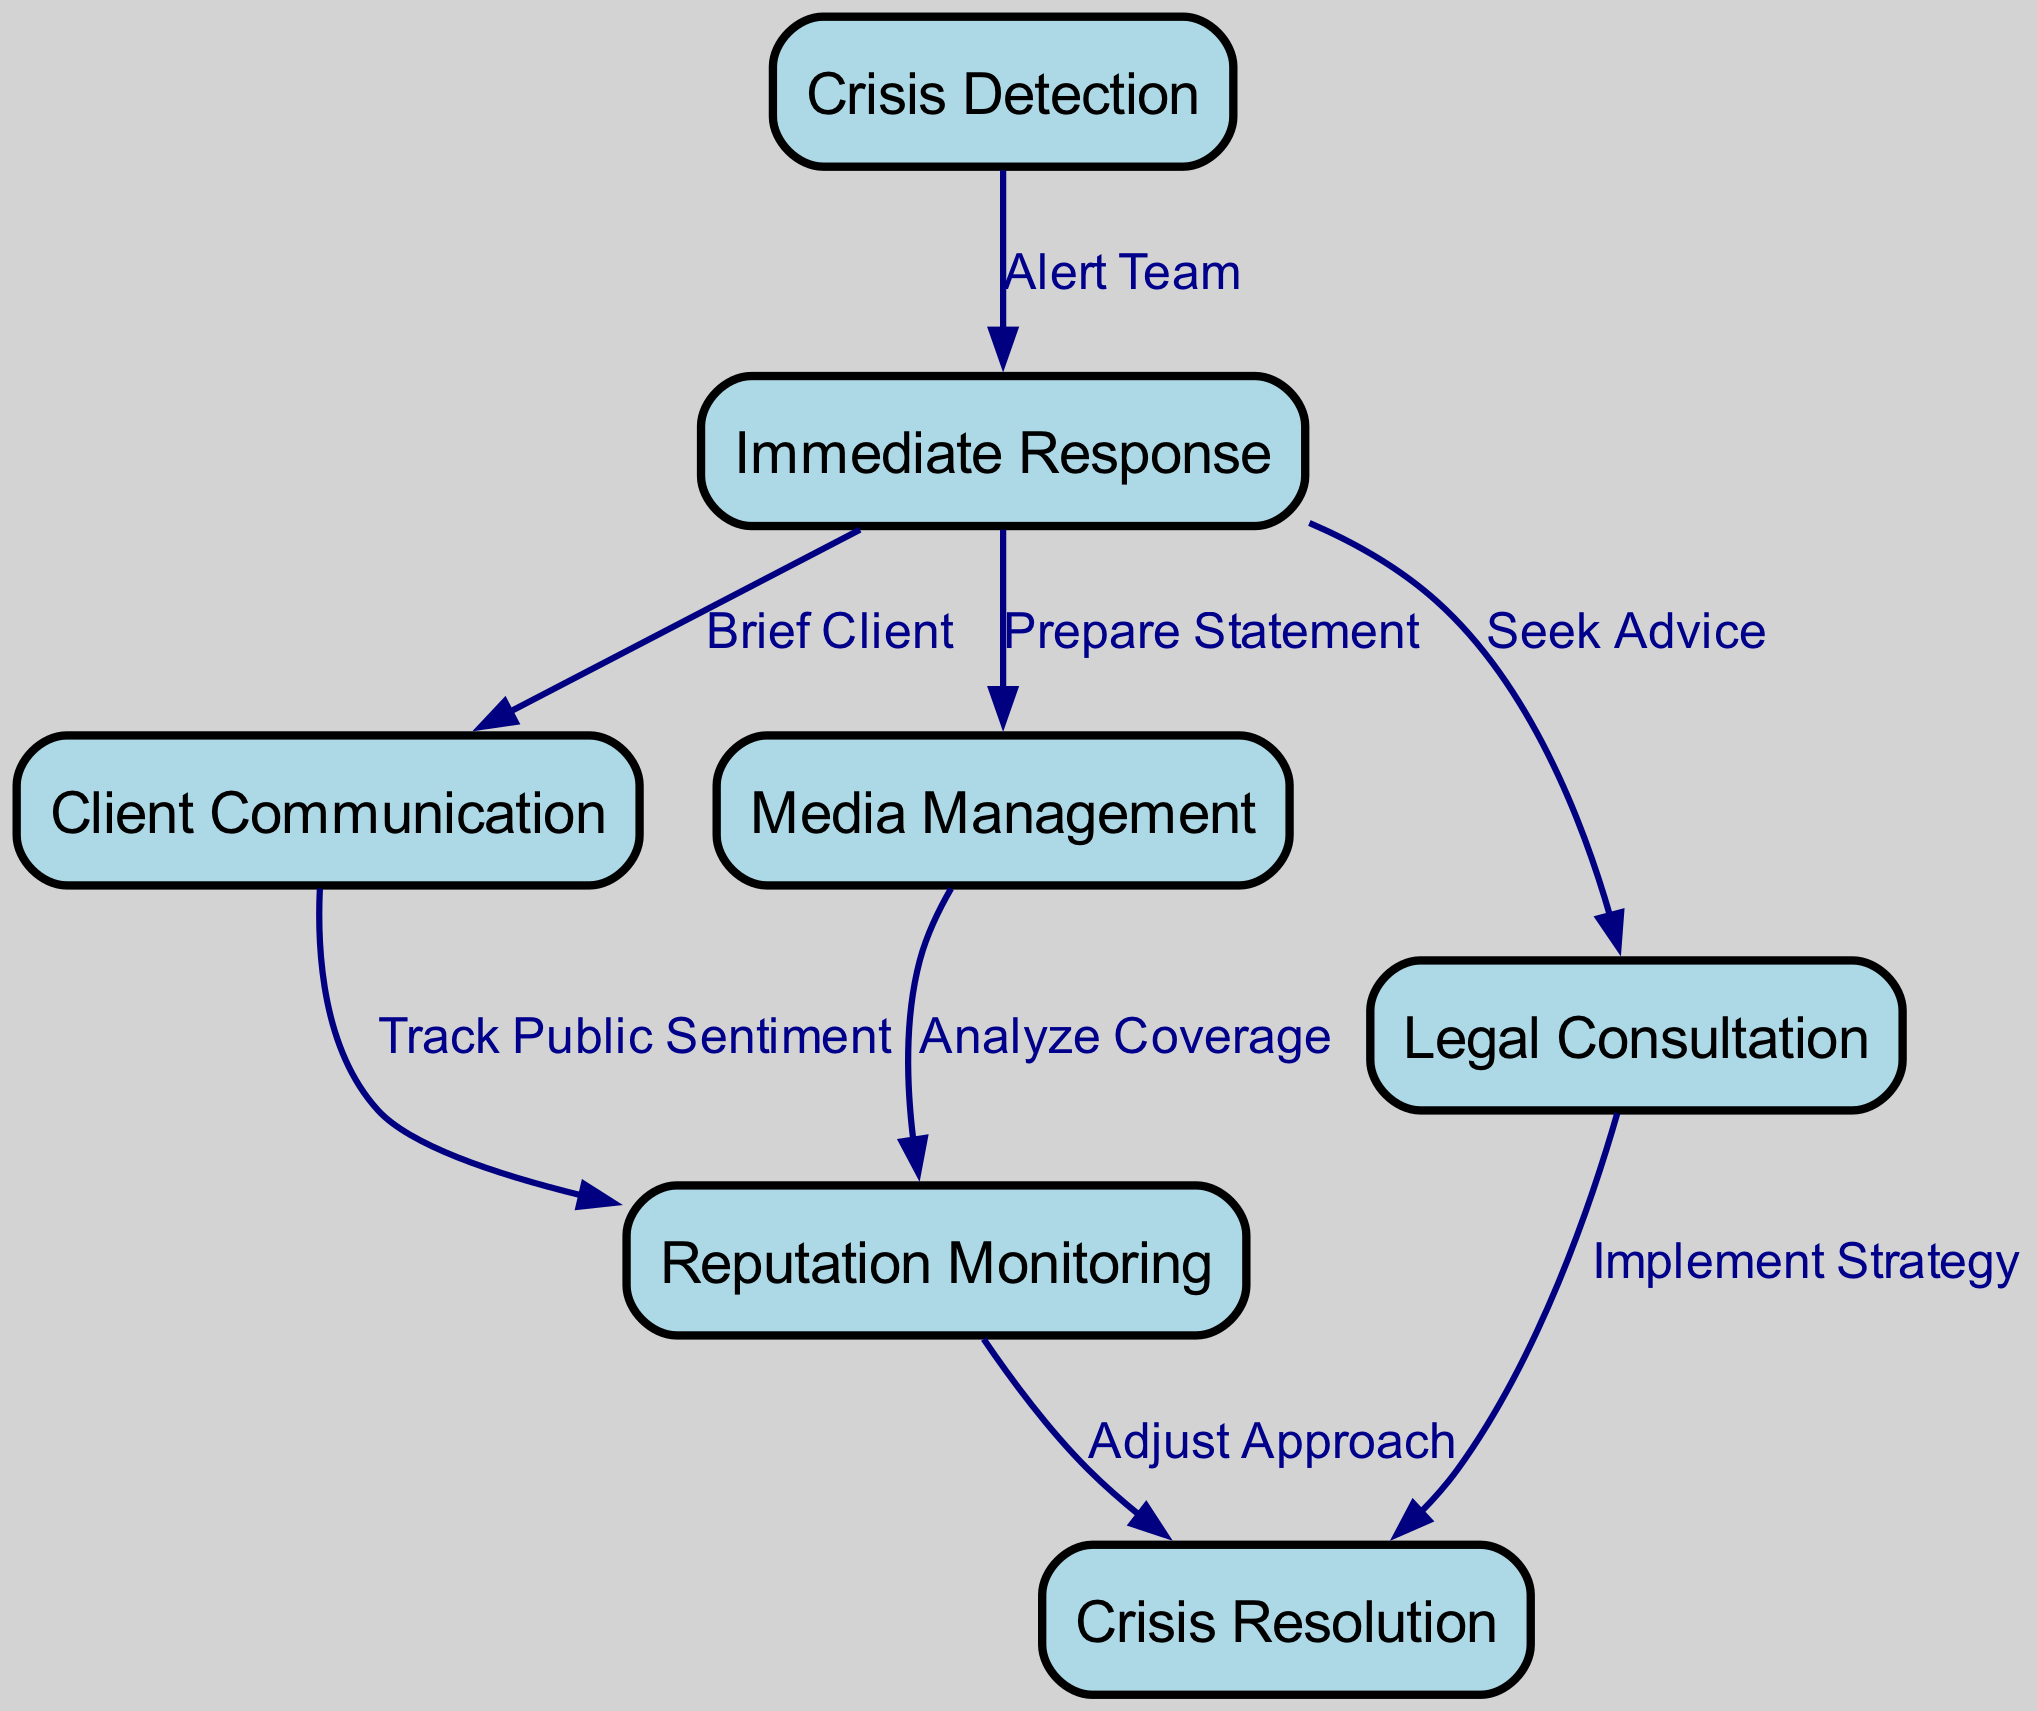What is the first step in the workflow? The first step is "Crisis Detection," which is the initial node in the diagram, indicating the starting point of the crisis management workflow.
Answer: Crisis Detection How many nodes are in the diagram? The diagram contains seven nodes, as indicated in the provided data structure under the "nodes" section.
Answer: 7 What is the relationship between "Immediate Response" and "Client Communication"? The relationship is established through the edge labeled "Brief Client," which connects "Immediate Response" to "Client Communication" and indicates that the client will be briefed as part of the immediate response.
Answer: Brief Client Which node follows "Legal Consultation"? "Crisis Resolution" follows "Legal Consultation," as indicated by the edge labeled "Implement Strategy," which connects "Legal Consultation" to "Crisis Resolution."
Answer: Crisis Resolution What phase involves tracking public sentiment? The phase that involves tracking public sentiment is "Reputation Monitoring," which is the node that follows "Client Communication," connected by the edge labeled "Track Public Sentiment."
Answer: Reputation Monitoring How does media coverage analysis relate to public sentiment? Media coverage analysis is related to public sentiment through "Reputation Monitoring." The "Media Management" node connects to "Reputation Monitoring" via the edge labeled "Analyze Coverage," indicating that media coverage impacts public sentiment analysis.
Answer: Analyze Coverage What is the last step in the crisis management workflow? The last step is "Crisis Resolution," which is the terminating node in the workflow, indicating the conclusion of the crisis management process.
Answer: Crisis Resolution Which action is taken after "Immediate Response"? After "Immediate Response," the action taken is "Client Communication," as indicated by the edge labeled "Brief Client," displaying the flow of actions following the initial response to a crisis.
Answer: Client Communication What are the two actions that follow the "Seek Advice" step? The two actions following "Seek Advice" are "Crisis Resolution" via "Implement Strategy" and "Reputation Monitoring" via "Adjust Approach," which indicates that after seeking legal advice, both the implementation of strategies and adjustments in approach occur.
Answer: Crisis Resolution, Reputation Monitoring 